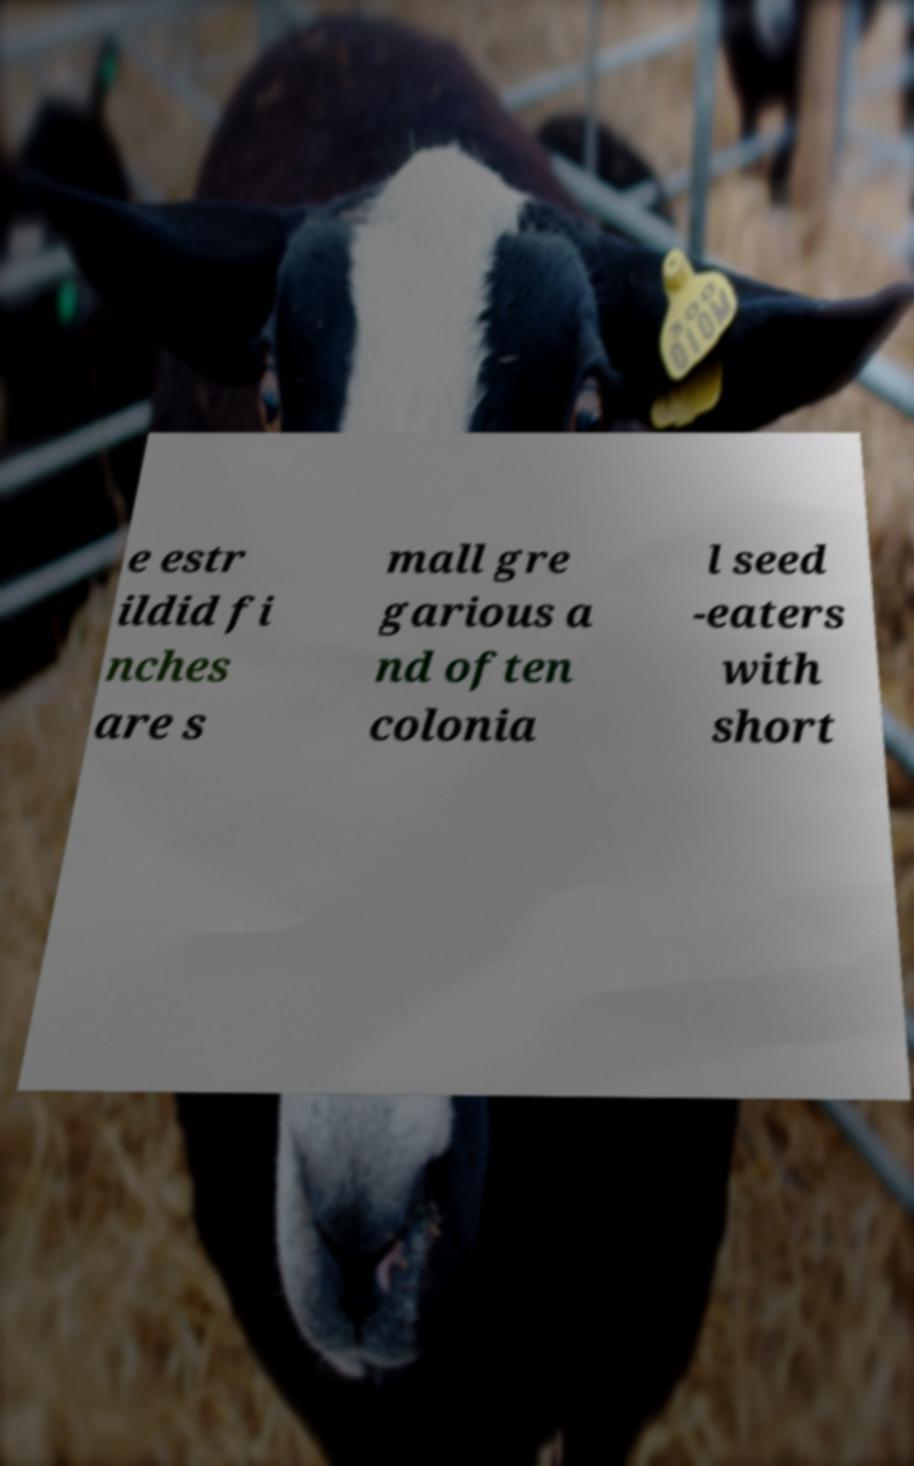Can you accurately transcribe the text from the provided image for me? e estr ildid fi nches are s mall gre garious a nd often colonia l seed -eaters with short 